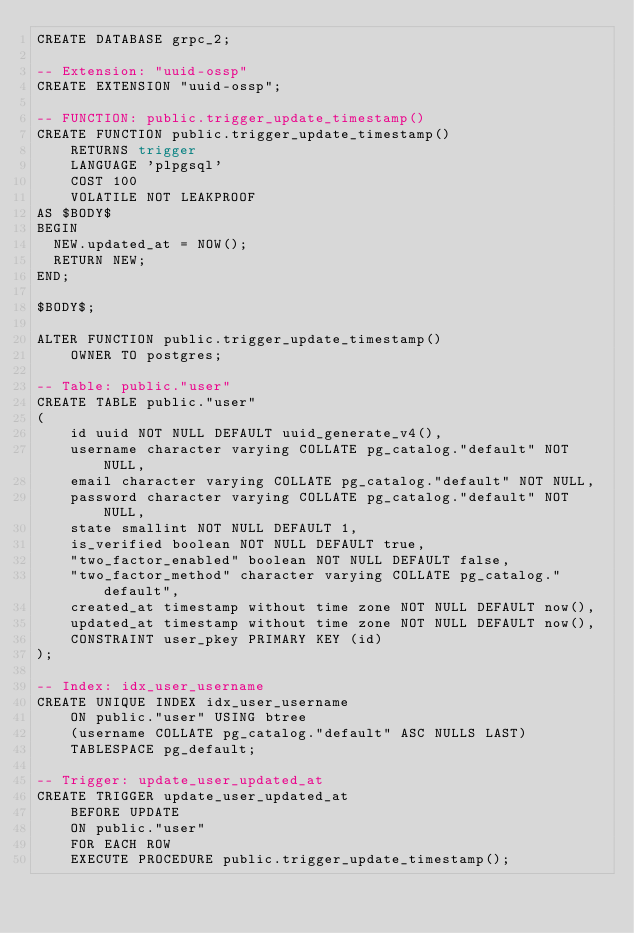Convert code to text. <code><loc_0><loc_0><loc_500><loc_500><_SQL_>CREATE DATABASE grpc_2;

-- Extension: "uuid-ossp"
CREATE EXTENSION "uuid-ossp";

-- FUNCTION: public.trigger_update_timestamp()
CREATE FUNCTION public.trigger_update_timestamp()
    RETURNS trigger
    LANGUAGE 'plpgsql'
    COST 100
    VOLATILE NOT LEAKPROOF
AS $BODY$
BEGIN
  NEW.updated_at = NOW();
  RETURN NEW;
END;

$BODY$;

ALTER FUNCTION public.trigger_update_timestamp()
    OWNER TO postgres;

-- Table: public."user"
CREATE TABLE public."user"
(
    id uuid NOT NULL DEFAULT uuid_generate_v4(),
    username character varying COLLATE pg_catalog."default" NOT NULL,
    email character varying COLLATE pg_catalog."default" NOT NULL,
    password character varying COLLATE pg_catalog."default" NOT NULL,
    state smallint NOT NULL DEFAULT 1,
    is_verified boolean NOT NULL DEFAULT true,
    "two_factor_enabled" boolean NOT NULL DEFAULT false,
    "two_factor_method" character varying COLLATE pg_catalog."default",
    created_at timestamp without time zone NOT NULL DEFAULT now(),
    updated_at timestamp without time zone NOT NULL DEFAULT now(),
    CONSTRAINT user_pkey PRIMARY KEY (id)
);

-- Index: idx_user_username
CREATE UNIQUE INDEX idx_user_username
    ON public."user" USING btree
    (username COLLATE pg_catalog."default" ASC NULLS LAST)
    TABLESPACE pg_default;

-- Trigger: update_user_updated_at
CREATE TRIGGER update_user_updated_at
    BEFORE UPDATE 
    ON public."user"
    FOR EACH ROW
    EXECUTE PROCEDURE public.trigger_update_timestamp();</code> 